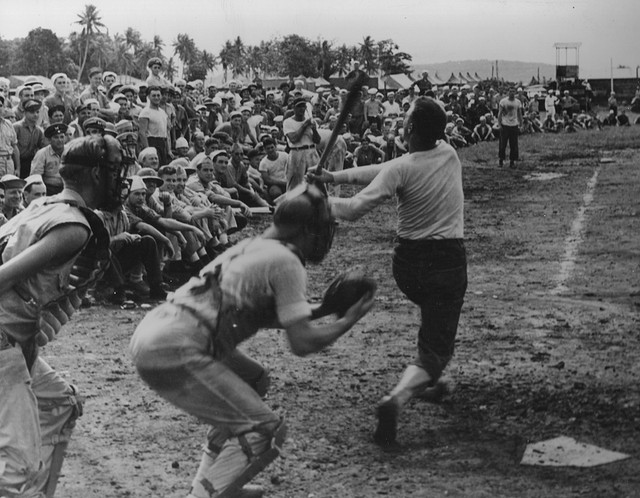<image>Which hand does the man have on the ground? I don't know which hand the man has on the ground. It could be neither, left, or right. Which hand does the man have on the ground? It is not certain which hand the man has on the ground. It can be neither left nor right. 